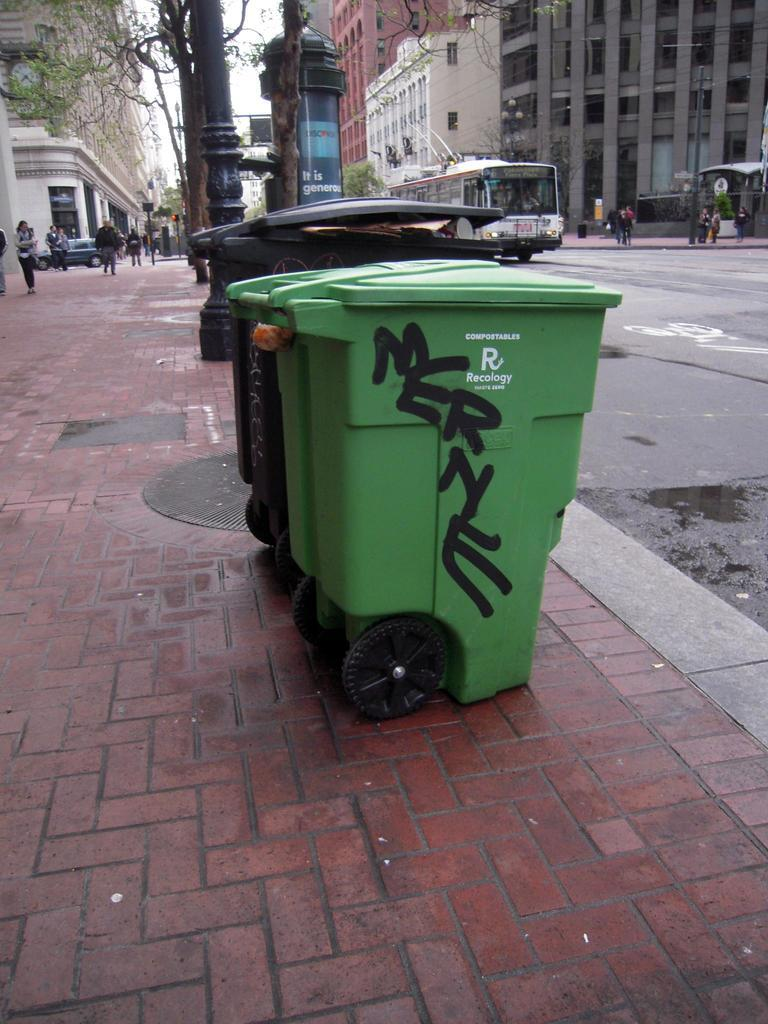<image>
Give a short and clear explanation of the subsequent image. The name Merne is written on the side of a green trash can on the curb in a city. 